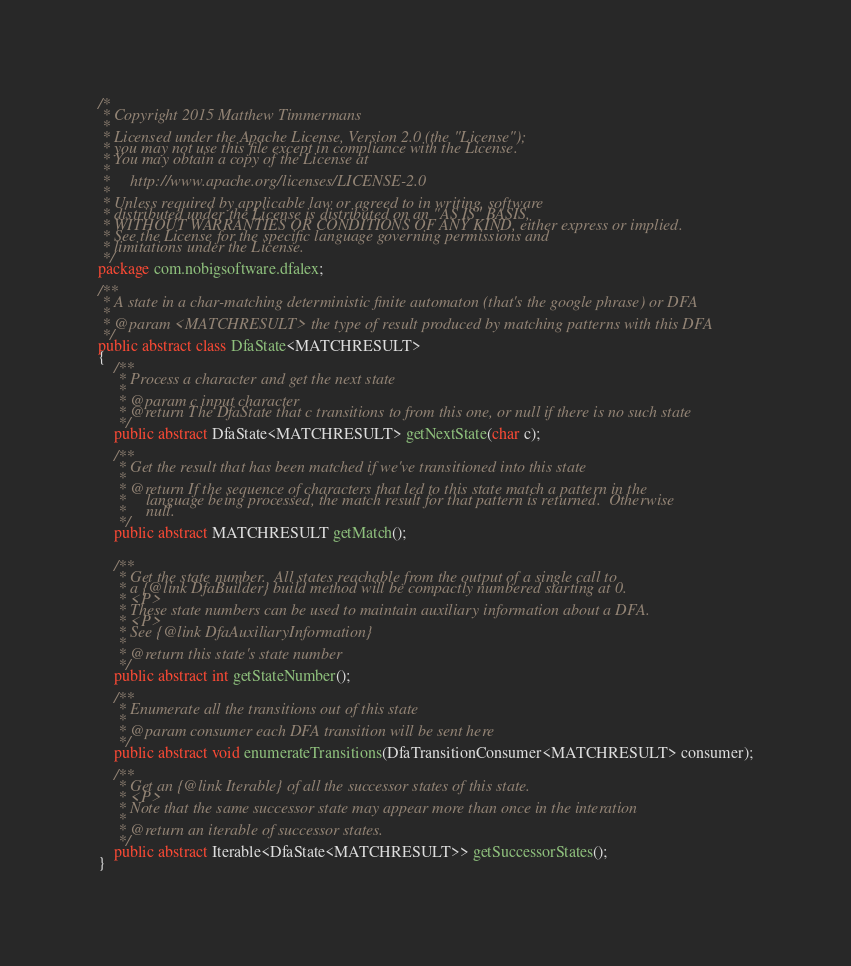<code> <loc_0><loc_0><loc_500><loc_500><_Java_>/*
 * Copyright 2015 Matthew Timmermans
 * 
 * Licensed under the Apache License, Version 2.0 (the "License");
 * you may not use this file except in compliance with the License.
 * You may obtain a copy of the License at
 * 
 *     http://www.apache.org/licenses/LICENSE-2.0
 * 
 * Unless required by applicable law or agreed to in writing, software
 * distributed under the License is distributed on an "AS IS" BASIS,
 * WITHOUT WARRANTIES OR CONDITIONS OF ANY KIND, either express or implied.
 * See the License for the specific language governing permissions and
 * limitations under the License.
 */
package com.nobigsoftware.dfalex;

/**
 * A state in a char-matching deterministic finite automaton (that's the google phrase) or DFA
 * 
 * @param <MATCHRESULT> the type of result produced by matching patterns with this DFA
 */
public abstract class DfaState<MATCHRESULT>
{
	/**
	 * Process a character and get the next state
	 * 
	 * @param c input character
	 * @return The DfaState that c transitions to from this one, or null if there is no such state
	 */
	public abstract DfaState<MATCHRESULT> getNextState(char c);
	
	/**
	 * Get the result that has been matched if we've transitioned into this state
	 * 
	 * @return If the sequence of characters that led to this state match a pattern in the
	 *     language being processed, the match result for that pattern is returned.  Otherwise
	 *     null.
	 */
	public abstract MATCHRESULT getMatch();
	
	
	/**
     * Get the state number.  All states reachable from the output of a single call to
     * a {@link DfaBuilder} build method will be compactly numbered starting at 0.
     * <P>
     * These state numbers can be used to maintain auxiliary information about a DFA.
     * <P>
     * See {@link DfaAuxiliaryInformation}
     * 
     * @return this state's state number
     */
    public abstract int getStateNumber();
    
    /**
     * Enumerate all the transitions out of this state
     * 
     * @param consumer each DFA transition will be sent here
     */
    public abstract void enumerateTransitions(DfaTransitionConsumer<MATCHRESULT> consumer);

    /**
     * Get an {@link Iterable} of all the successor states of this state.
     * <P>
     * Note that the same successor state may appear more than once in the interation
     * 
     * @return an iterable of successor states.
     */
    public abstract Iterable<DfaState<MATCHRESULT>> getSuccessorStates();
}
</code> 